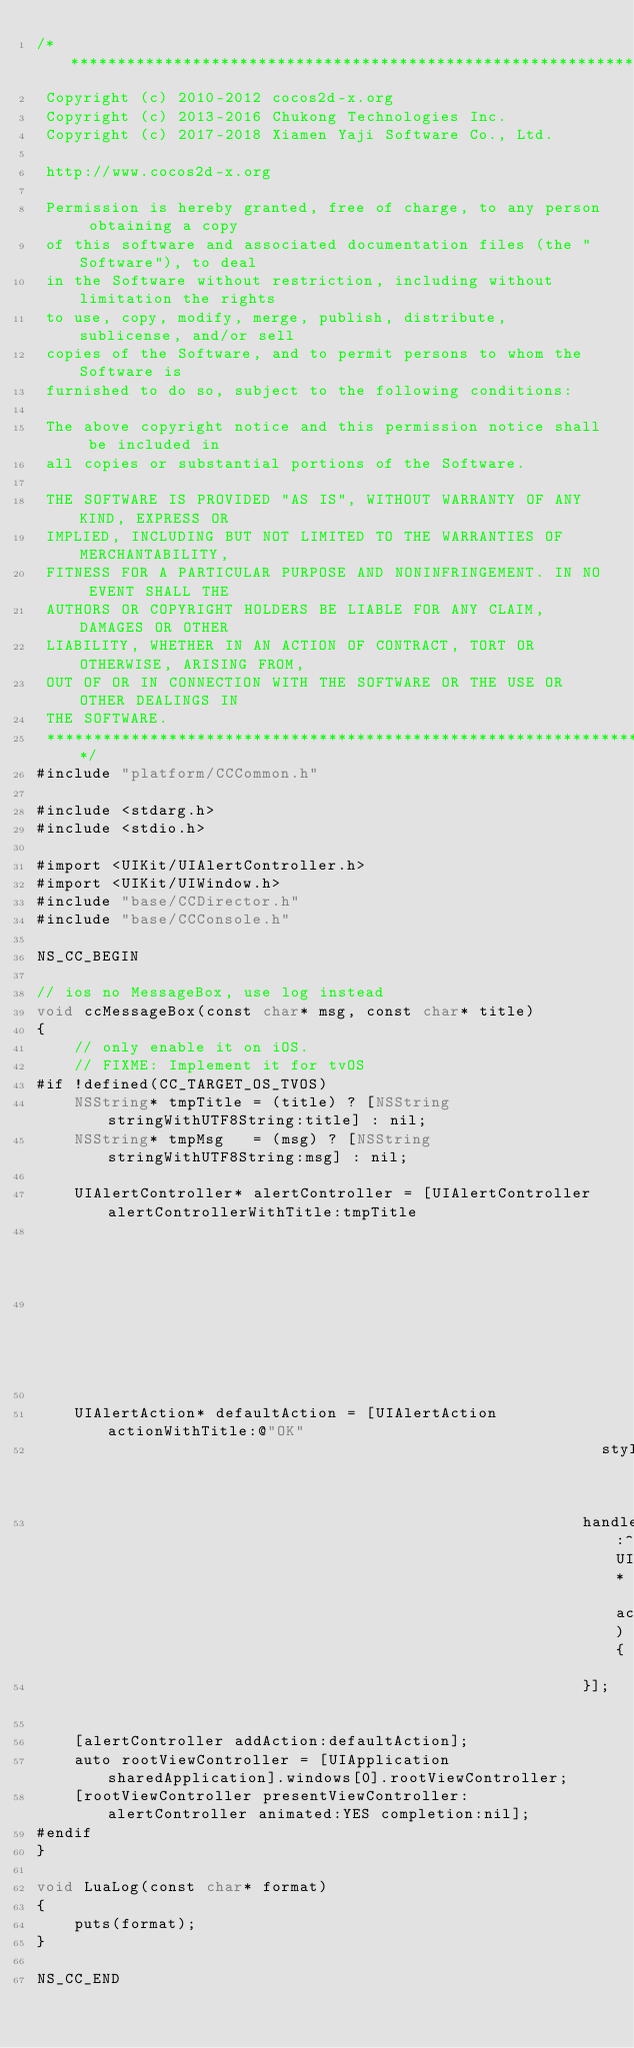Convert code to text. <code><loc_0><loc_0><loc_500><loc_500><_ObjectiveC_>/****************************************************************************
 Copyright (c) 2010-2012 cocos2d-x.org
 Copyright (c) 2013-2016 Chukong Technologies Inc.
 Copyright (c) 2017-2018 Xiamen Yaji Software Co., Ltd.

 http://www.cocos2d-x.org

 Permission is hereby granted, free of charge, to any person obtaining a copy
 of this software and associated documentation files (the "Software"), to deal
 in the Software without restriction, including without limitation the rights
 to use, copy, modify, merge, publish, distribute, sublicense, and/or sell
 copies of the Software, and to permit persons to whom the Software is
 furnished to do so, subject to the following conditions:

 The above copyright notice and this permission notice shall be included in
 all copies or substantial portions of the Software.

 THE SOFTWARE IS PROVIDED "AS IS", WITHOUT WARRANTY OF ANY KIND, EXPRESS OR
 IMPLIED, INCLUDING BUT NOT LIMITED TO THE WARRANTIES OF MERCHANTABILITY,
 FITNESS FOR A PARTICULAR PURPOSE AND NONINFRINGEMENT. IN NO EVENT SHALL THE
 AUTHORS OR COPYRIGHT HOLDERS BE LIABLE FOR ANY CLAIM, DAMAGES OR OTHER
 LIABILITY, WHETHER IN AN ACTION OF CONTRACT, TORT OR OTHERWISE, ARISING FROM,
 OUT OF OR IN CONNECTION WITH THE SOFTWARE OR THE USE OR OTHER DEALINGS IN
 THE SOFTWARE.
 ****************************************************************************/
#include "platform/CCCommon.h"

#include <stdarg.h>
#include <stdio.h>

#import <UIKit/UIAlertController.h>
#import <UIKit/UIWindow.h>
#include "base/CCDirector.h"
#include "base/CCConsole.h"

NS_CC_BEGIN

// ios no MessageBox, use log instead
void ccMessageBox(const char* msg, const char* title)
{
    // only enable it on iOS.
    // FIXME: Implement it for tvOS
#if !defined(CC_TARGET_OS_TVOS)
    NSString* tmpTitle = (title) ? [NSString stringWithUTF8String:title] : nil;
    NSString* tmpMsg   = (msg) ? [NSString stringWithUTF8String:msg] : nil;

    UIAlertController* alertController = [UIAlertController alertControllerWithTitle:tmpTitle
                                                                             message:tmpMsg
                                                                      preferredStyle:UIAlertControllerStyleAlert];

    UIAlertAction* defaultAction = [UIAlertAction actionWithTitle:@"OK"
                                                            style:UIAlertActionStyleDefault
                                                          handler:^(UIAlertAction* action){
                                                          }];

    [alertController addAction:defaultAction];
    auto rootViewController = [UIApplication sharedApplication].windows[0].rootViewController;
    [rootViewController presentViewController:alertController animated:YES completion:nil];
#endif
}

void LuaLog(const char* format)
{
    puts(format);
}

NS_CC_END
</code> 